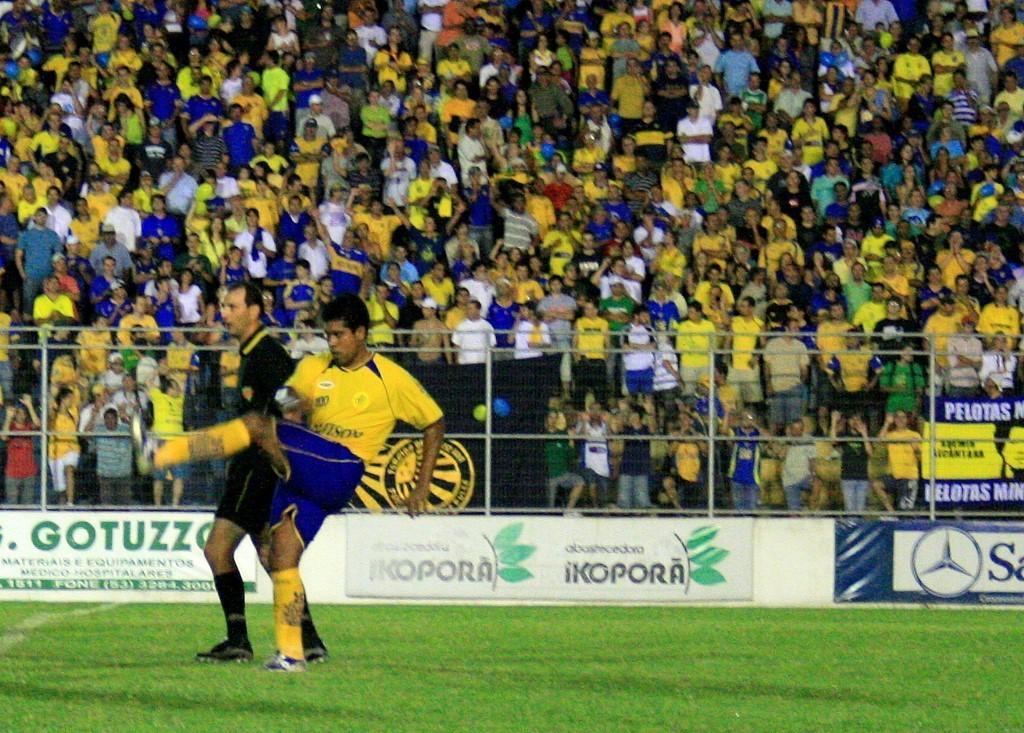Can you describe this image briefly? At the bottom of the image there is a grass on the ground. On the ground at the left side there is a man with yellow t-shirt is standing. Behind him there is another person with black dress is standing on the ground. Behind them there are few posts with fencing. Behind the fencing there is a crowd. 